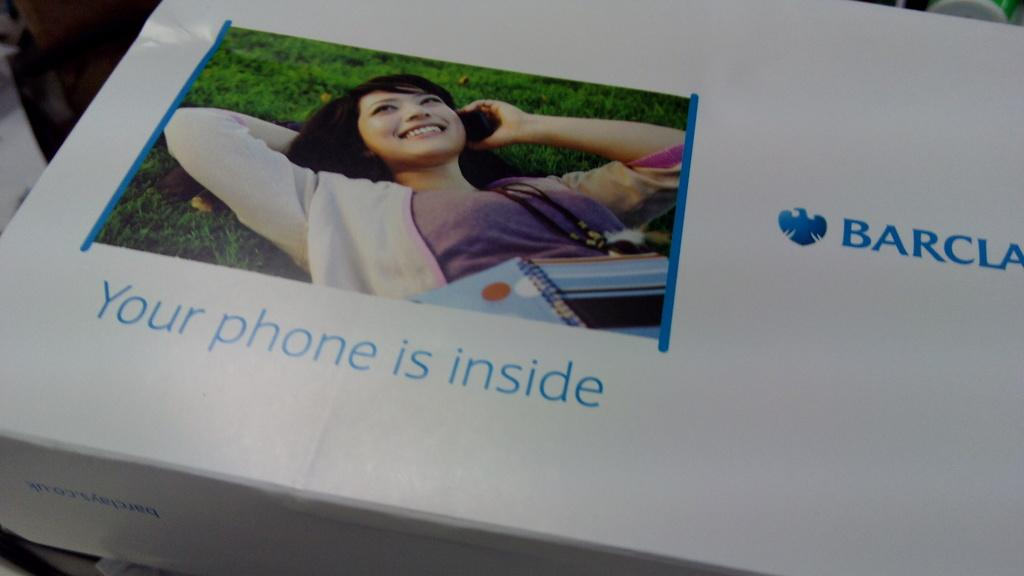What object is the main focus of the image? There is a box in the image. What is depicted on the box? There is a photo of a woman on the box. What is the woman in the photo doing? The woman in the photo is sleeping on the grass. What objects is the woman in the photo holding? The woman in the photo is holding a mobile and a book. What is written on the paper in the image? There is text on a paper in the image. How would you describe the overall appearance of the image? The background of the image is blurred. What type of bone can be seen in the woman's hand in the image? There is no bone visible in the woman's hand in the image. How many spoons are present in the image? There is no spoon mentioned or visible in the image. 